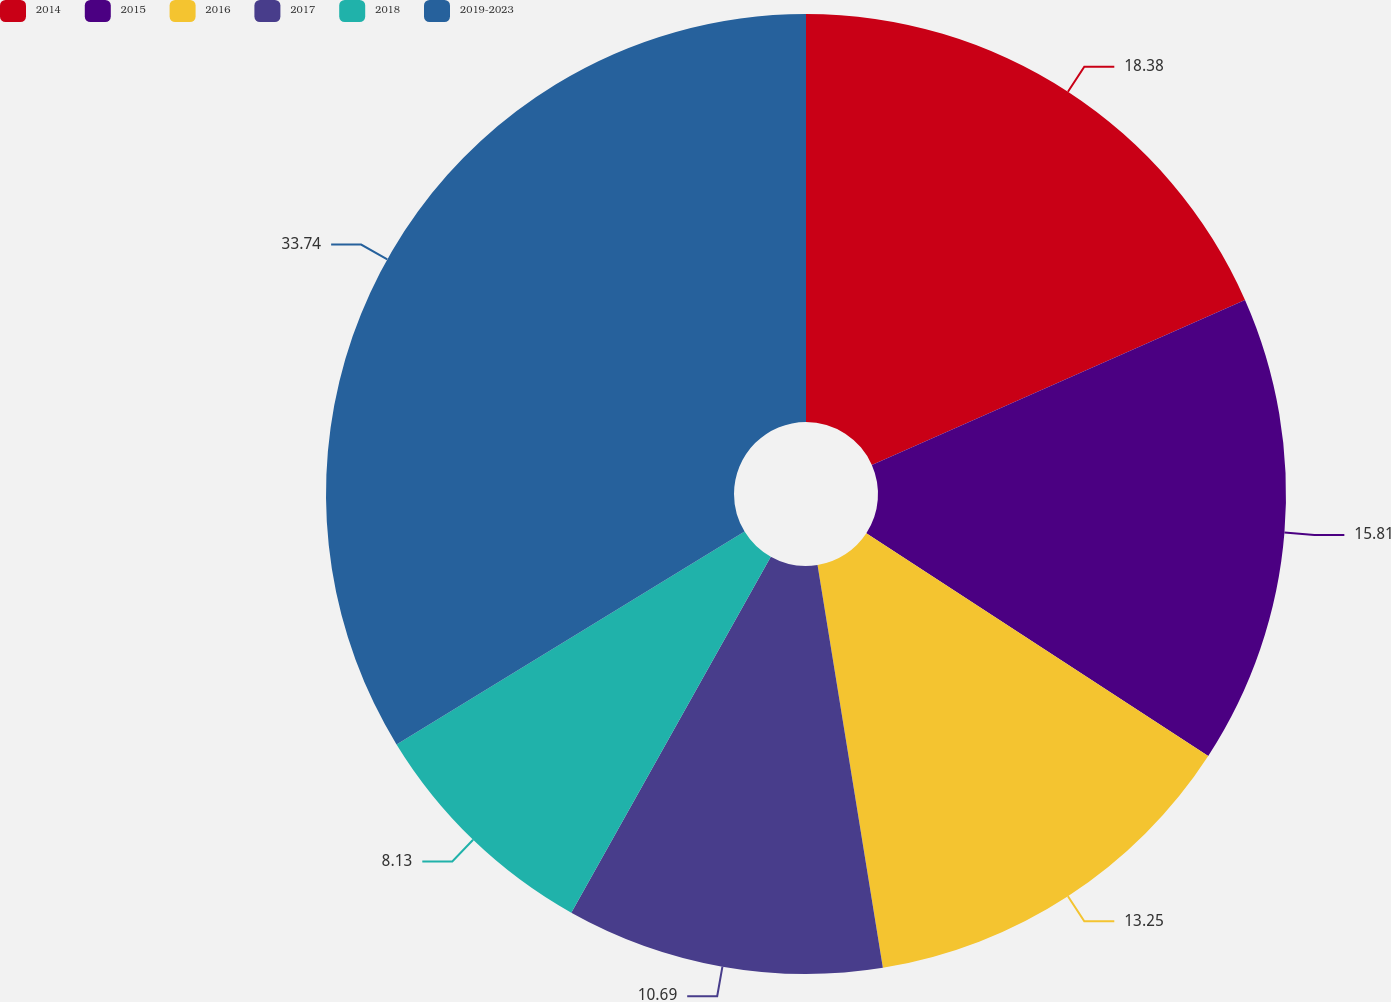Convert chart. <chart><loc_0><loc_0><loc_500><loc_500><pie_chart><fcel>2014<fcel>2015<fcel>2016<fcel>2017<fcel>2018<fcel>2019-2023<nl><fcel>18.37%<fcel>15.81%<fcel>13.25%<fcel>10.69%<fcel>8.13%<fcel>33.73%<nl></chart> 